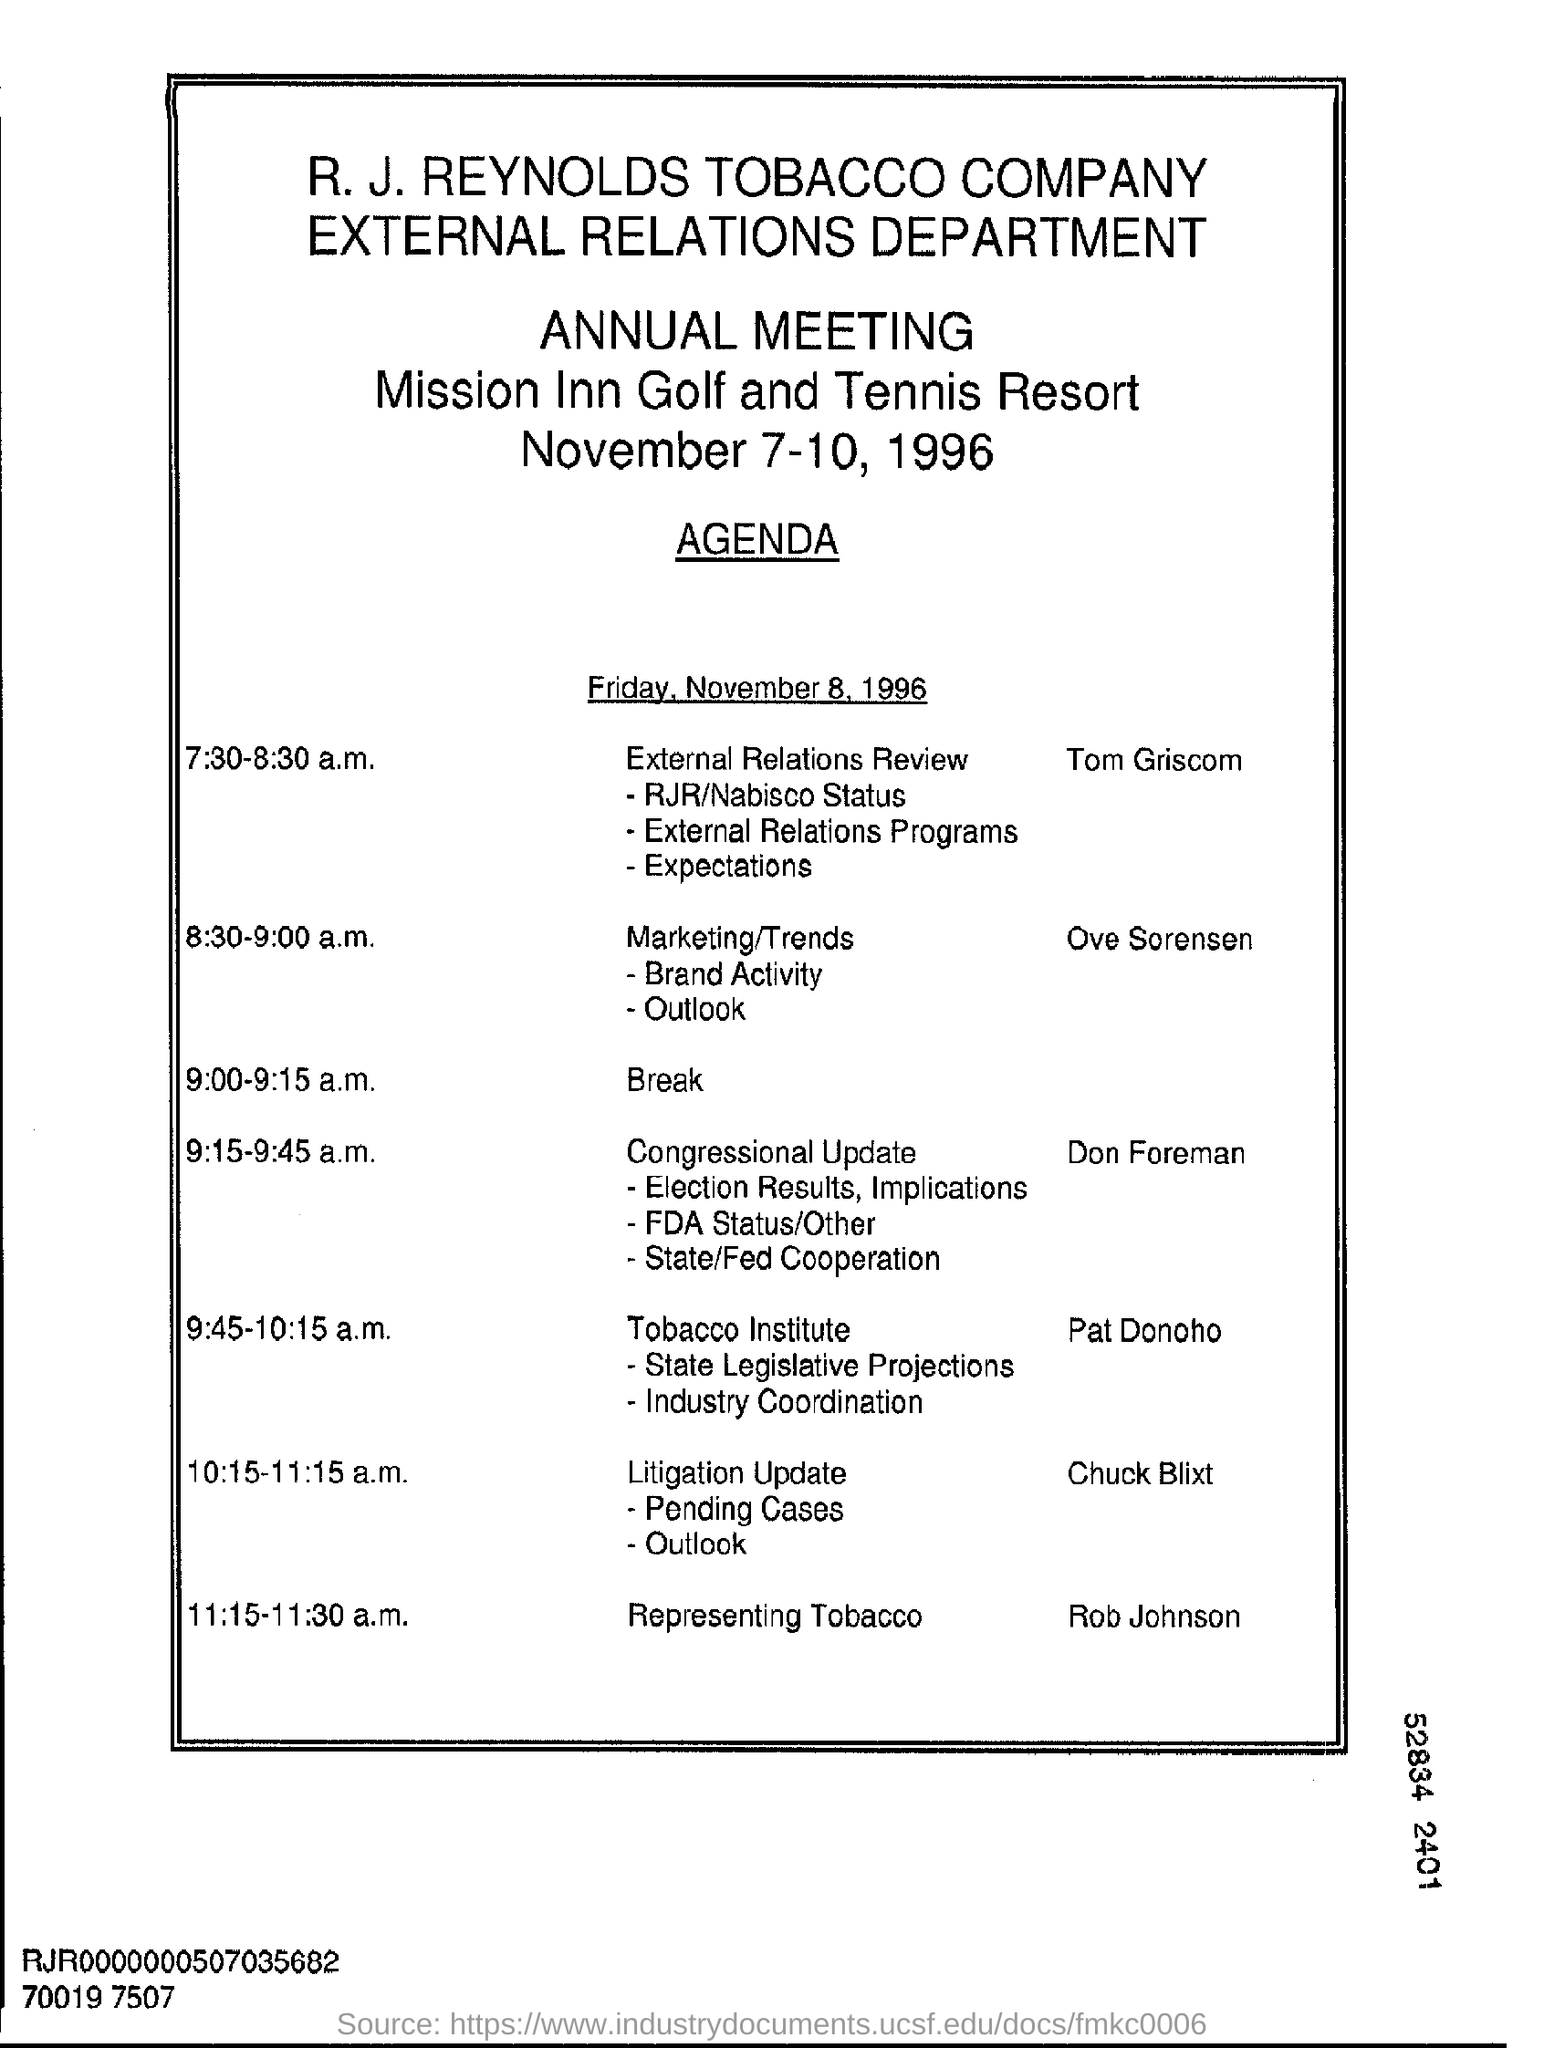What is the date of annual meeting?
Your response must be concise. November 7-10, 1996. What is the timing of meeting of external relations review?
Offer a terse response. 7:30-8:30 a.m. What is the break time for annual meeting ?
Offer a terse response. 9:00-9:15 a.m. What is the name of department ?
Ensure brevity in your answer.  EXTERNAL RELATIONS. What is the name of company on the letter head?
Offer a very short reply. R. J. REYNOLDS TOBACCO COMPANY. What is the name of person who represented the tobacco in the meeting?
Ensure brevity in your answer.  Rob Johnson. What is the name of person who discussed the marketing/trends at 8:30- 9:00am?
Offer a very short reply. Ove Sorensen. 